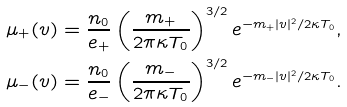Convert formula to latex. <formula><loc_0><loc_0><loc_500><loc_500>\mu _ { + } ( v ) & = \frac { n _ { 0 } } { e _ { + } } \left ( \frac { m _ { + } } { 2 \pi \kappa T _ { 0 } } \right ) ^ { 3 / 2 } e ^ { - m _ { + } | v | ^ { 2 } / 2 \kappa T _ { 0 } } , \\ \mu _ { - } ( v ) & = \frac { n _ { 0 } } { e _ { - } } \left ( \frac { m _ { - } } { 2 \pi \kappa T _ { 0 } } \right ) ^ { 3 / 2 } e ^ { - m _ { - } | v | ^ { 2 } / 2 \kappa T _ { 0 } } .</formula> 